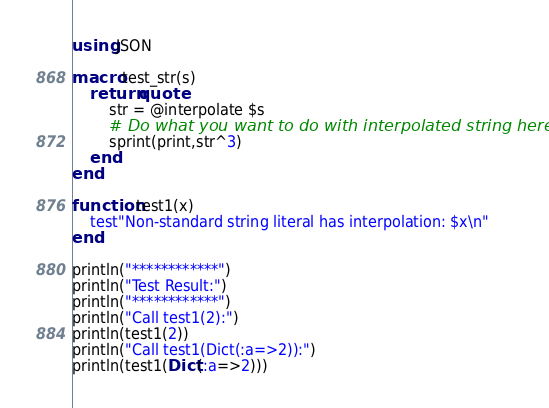Convert code to text. <code><loc_0><loc_0><loc_500><loc_500><_Julia_>using JSON

macro test_str(s)
    return quote
        str = @interpolate $s
        # Do what you want to do with interpolated string here.
        sprint(print,str^3)
    end
end

function test1(x)
    test"Non-standard string literal has interpolation: $x\n"
end

println("************")
println("Test Result:")
println("************")
println("Call test1(2):")
println(test1(2))
println("Call test1(Dict(:a=>2)):")
println(test1(Dict(:a=>2)))
</code> 